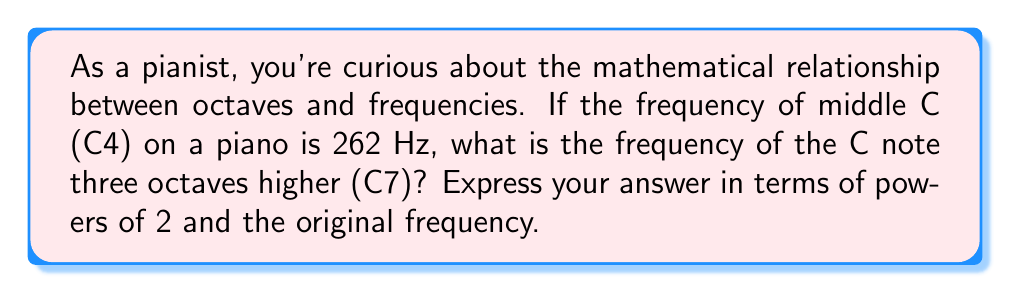Could you help me with this problem? Let's approach this step-by-step:

1) First, recall that each octave represents a doubling of frequency. So, moving up one octave multiplies the frequency by 2.

2) We're moving up three octaves, so we need to multiply by 2 three times. This can be expressed as a power of 2:

   $$ 262 \text{ Hz} \cdot 2^3 $$

3) Now, let's use the properties of logarithms to simplify this expression. We can write this as:

   $$ 262 \cdot 2^3 \text{ Hz} $$

4) This can be further simplified by recognizing that 262 Hz is our starting frequency for C4. Let's call this frequency $f$. So our expression becomes:

   $$ f \cdot 2^3 \text{ Hz} $$

5) In general, for $n$ octaves above a starting frequency $f$, the new frequency would be:

   $$ f \cdot 2^n \text{ Hz} $$

6) In our case, $n = 3$ and $f = 262 \text{ Hz}$.

This expression, $f \cdot 2^3$, represents the frequency of C7 in terms of powers of 2 and the original frequency of C4.
Answer: $f \cdot 2^3 \text{ Hz}$ 